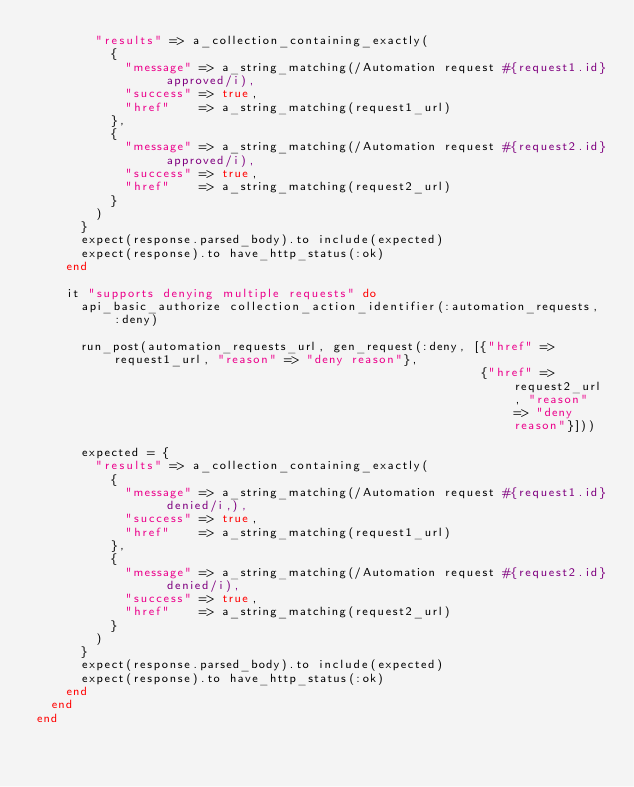<code> <loc_0><loc_0><loc_500><loc_500><_Ruby_>        "results" => a_collection_containing_exactly(
          {
            "message" => a_string_matching(/Automation request #{request1.id} approved/i),
            "success" => true,
            "href"    => a_string_matching(request1_url)
          },
          {
            "message" => a_string_matching(/Automation request #{request2.id} approved/i),
            "success" => true,
            "href"    => a_string_matching(request2_url)
          }
        )
      }
      expect(response.parsed_body).to include(expected)
      expect(response).to have_http_status(:ok)
    end

    it "supports denying multiple requests" do
      api_basic_authorize collection_action_identifier(:automation_requests, :deny)

      run_post(automation_requests_url, gen_request(:deny, [{"href" => request1_url, "reason" => "deny reason"},
                                                            {"href" => request2_url, "reason" => "deny reason"}]))

      expected = {
        "results" => a_collection_containing_exactly(
          {
            "message" => a_string_matching(/Automation request #{request1.id} denied/i,),
            "success" => true,
            "href"    => a_string_matching(request1_url)
          },
          {
            "message" => a_string_matching(/Automation request #{request2.id} denied/i),
            "success" => true,
            "href"    => a_string_matching(request2_url)
          }
        )
      }
      expect(response.parsed_body).to include(expected)
      expect(response).to have_http_status(:ok)
    end
  end
end
</code> 